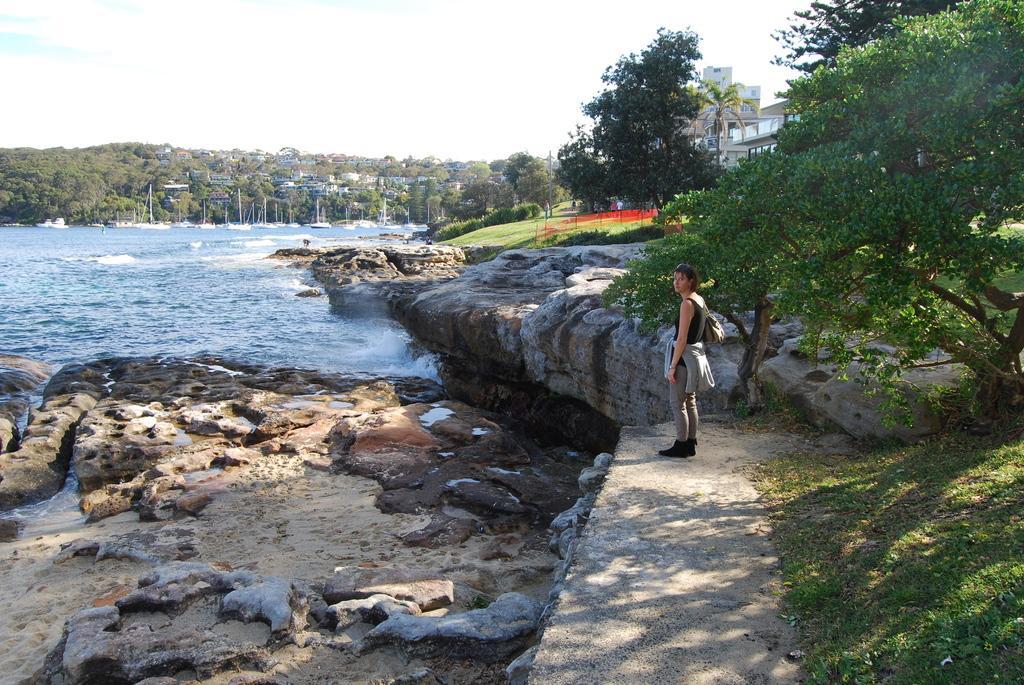Please provide a concise description of this image. This is the woman standing on the pathway. These look like the rocks. Here is the grass. I can see the trees and bushes. Here is the water flowing. In the background, I can see the houses and buildings. These look like the boats on the water. This is the sky. 